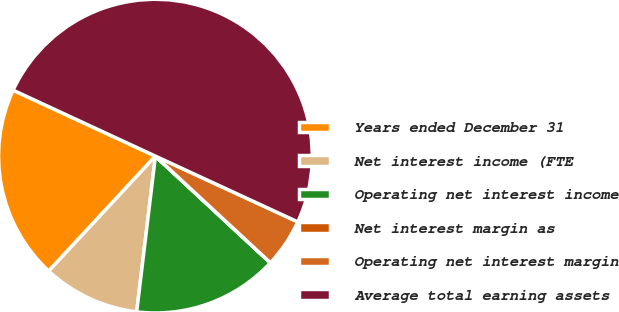<chart> <loc_0><loc_0><loc_500><loc_500><pie_chart><fcel>Years ended December 31<fcel>Net interest income (FTE<fcel>Operating net interest income<fcel>Net interest margin as<fcel>Operating net interest margin<fcel>Average total earning assets<nl><fcel>20.0%<fcel>10.0%<fcel>15.0%<fcel>0.01%<fcel>5.01%<fcel>49.98%<nl></chart> 